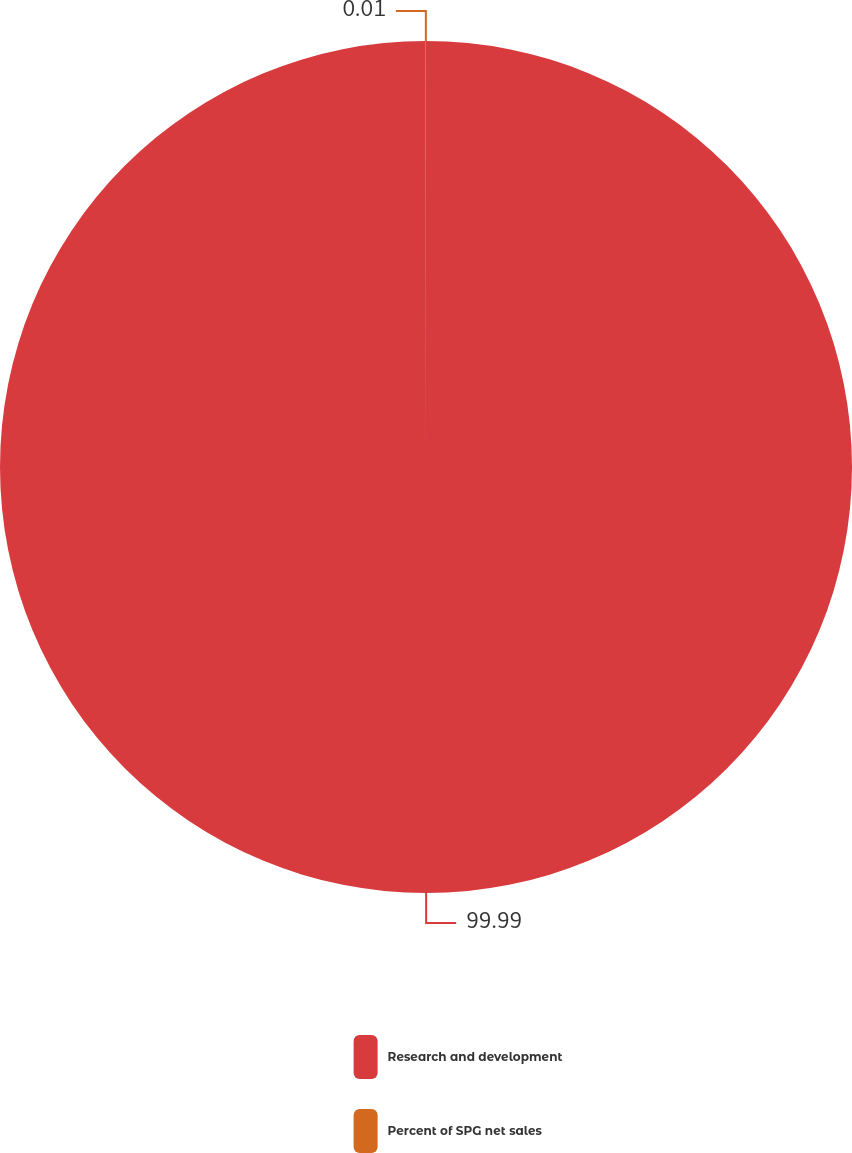Convert chart to OTSL. <chart><loc_0><loc_0><loc_500><loc_500><pie_chart><fcel>Research and development<fcel>Percent of SPG net sales<nl><fcel>99.99%<fcel>0.01%<nl></chart> 